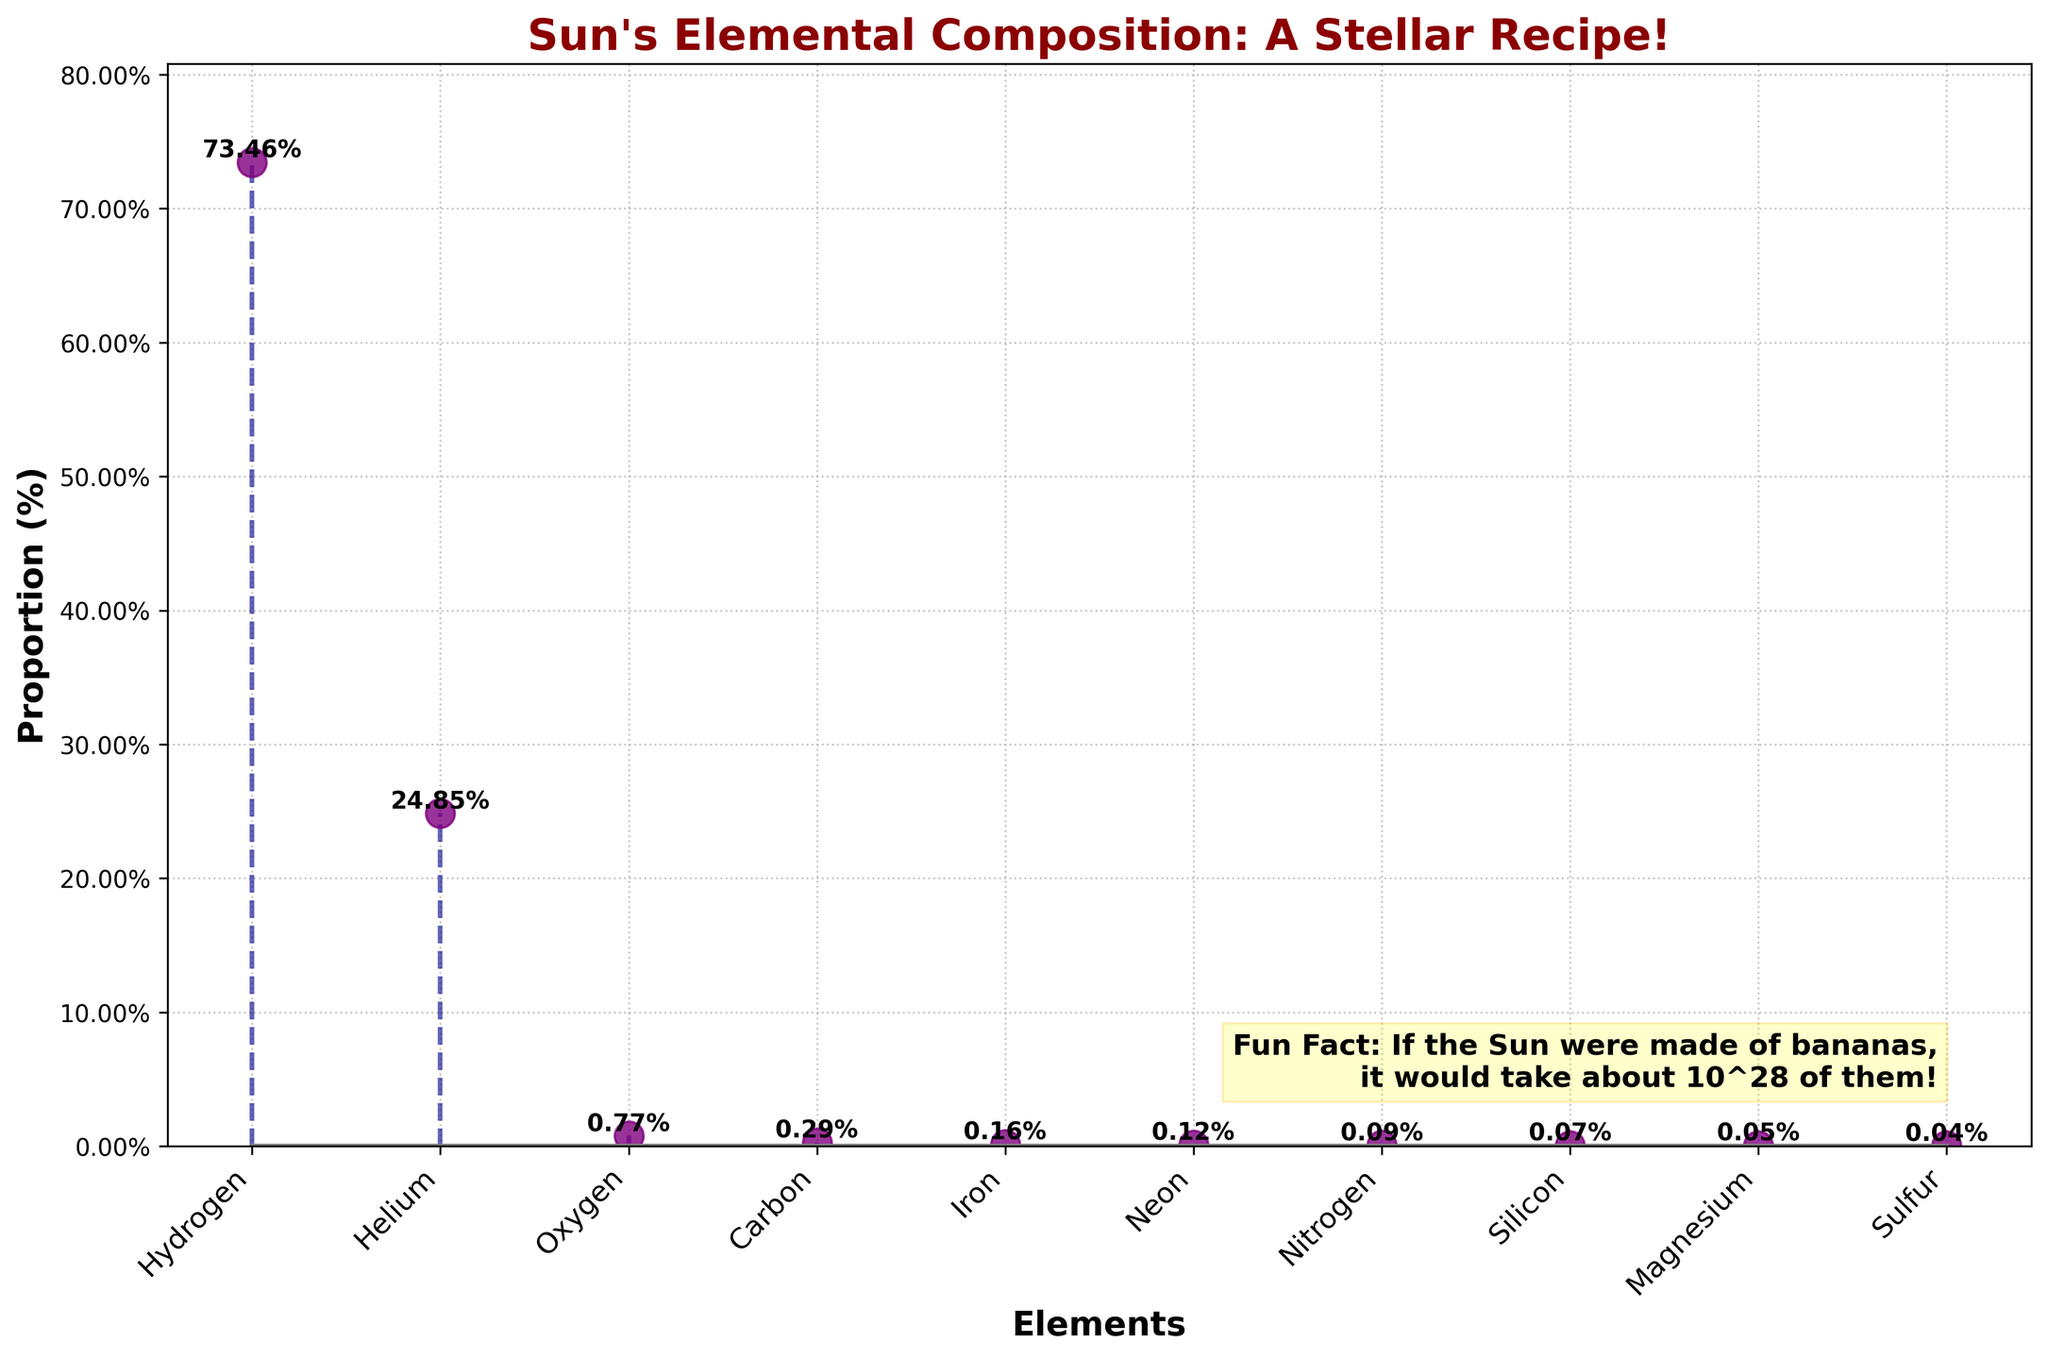Why are hydrogen and helium the most abundant elements in the Sun? By looking at the stem plot, hydrogen and helium have the highest proportional values compared to other elements, which makes them the most abundant. This reflects the Sun's primary composition, which is about 73.46% hydrogen and 24.85% helium.
Answer: They are the most abundant elements in the Sun Which element has the smallest proportion in the Sun's composition? From the stem plot, the element with the smallest proportion (0.04%) is sulfur. Its marker is aligned significantly lower compared to other elements in the plot.
Answer: Sulfur What is the combined proportion of oxygen, carbon, and iron? To find the combined proportion, add the proportions of oxygen (0.77%), carbon (0.29%), and iron (0.16%). Calculation: 0.77% + 0.29% + 0.16% = 1.22%.
Answer: 1.22% How does the proportion of magnesium compare to that of silicon? By examining the plot, we can see that magnesium has a proportion of 0.05%, while silicon has a proportion of 0.07%. Thus, magnesium's proportion is less than silicon's proportion.
Answer: Magnesium's proportion is less than silicon's What is the median value of the proportions of all elements shown? To find the median, list all the proportions in ascending order: 0.04%, 0.05%, 0.07%, 0.09%, 0.12%, 0.16%, 0.29%, 0.77%, 24.85%, 73.46%. Since there are 10 elements, the median will be the average of the 5th and 6th values: (0.12% + 0.16%) / 2 = 0.14%.
Answer: 0.14% Which element has the second highest proportion after hydrogen? By looking at the plot, we see that helium has the second highest proportion at 24.85%, right after hydrogen.
Answer: Helium How many elements have a proportion less than 1%? By visually inspecting the stem plot, all elements except hydrogen (73.46%) and helium (24.85%) have proportions less than 1%. The count of such elements is 8.
Answer: 8 How much more abundant is hydrogen compared to neon? From the plot, hydrogen has a proportion of 73.46%, and neon has 0.12%. The difference is 73.46% - 0.12% = 73.34%.
Answer: 73.34% more abundant If silicon's proportion doubled, how would it compare to nitrogen's proportion? Doubling silicon's proportion (0.07%) gives us 0.07% * 2 = 0.14%. When compared to nitrogen's proportion (0.09%), silicon would then have a larger proportion.
Answer: Silicon's proportion would be larger What quirky fact about the Sun is mentioned in the plot? The plot includes a fun fact in text: "If the Sun were made of bananas, it would take about 10^28 of them!"
Answer: 10^28 bananas 